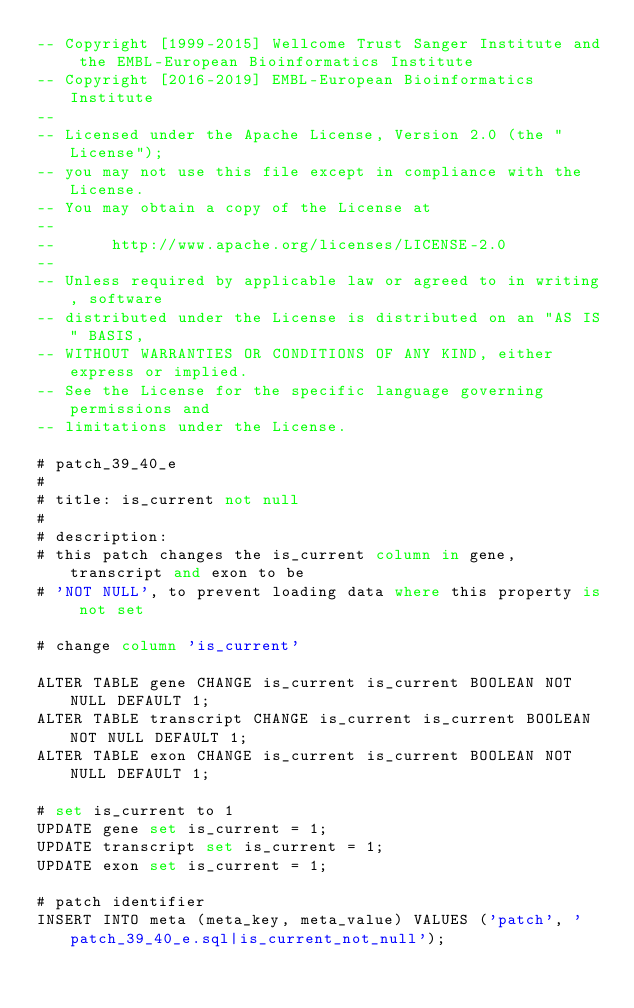Convert code to text. <code><loc_0><loc_0><loc_500><loc_500><_SQL_>-- Copyright [1999-2015] Wellcome Trust Sanger Institute and the EMBL-European Bioinformatics Institute
-- Copyright [2016-2019] EMBL-European Bioinformatics Institute
-- 
-- Licensed under the Apache License, Version 2.0 (the "License");
-- you may not use this file except in compliance with the License.
-- You may obtain a copy of the License at
-- 
--      http://www.apache.org/licenses/LICENSE-2.0
-- 
-- Unless required by applicable law or agreed to in writing, software
-- distributed under the License is distributed on an "AS IS" BASIS,
-- WITHOUT WARRANTIES OR CONDITIONS OF ANY KIND, either express or implied.
-- See the License for the specific language governing permissions and
-- limitations under the License.

# patch_39_40_e
#
# title: is_current not null
#
# description:
# this patch changes the is_current column in gene, transcript and exon to be
# 'NOT NULL', to prevent loading data where this property is not set

# change column 'is_current'

ALTER TABLE gene CHANGE is_current is_current BOOLEAN NOT NULL DEFAULT 1;
ALTER TABLE transcript CHANGE is_current is_current BOOLEAN NOT NULL DEFAULT 1;
ALTER TABLE exon CHANGE is_current is_current BOOLEAN NOT NULL DEFAULT 1;

# set is_current to 1
UPDATE gene set is_current = 1;
UPDATE transcript set is_current = 1;
UPDATE exon set is_current = 1;

# patch identifier
INSERT INTO meta (meta_key, meta_value) VALUES ('patch', 'patch_39_40_e.sql|is_current_not_null');

</code> 